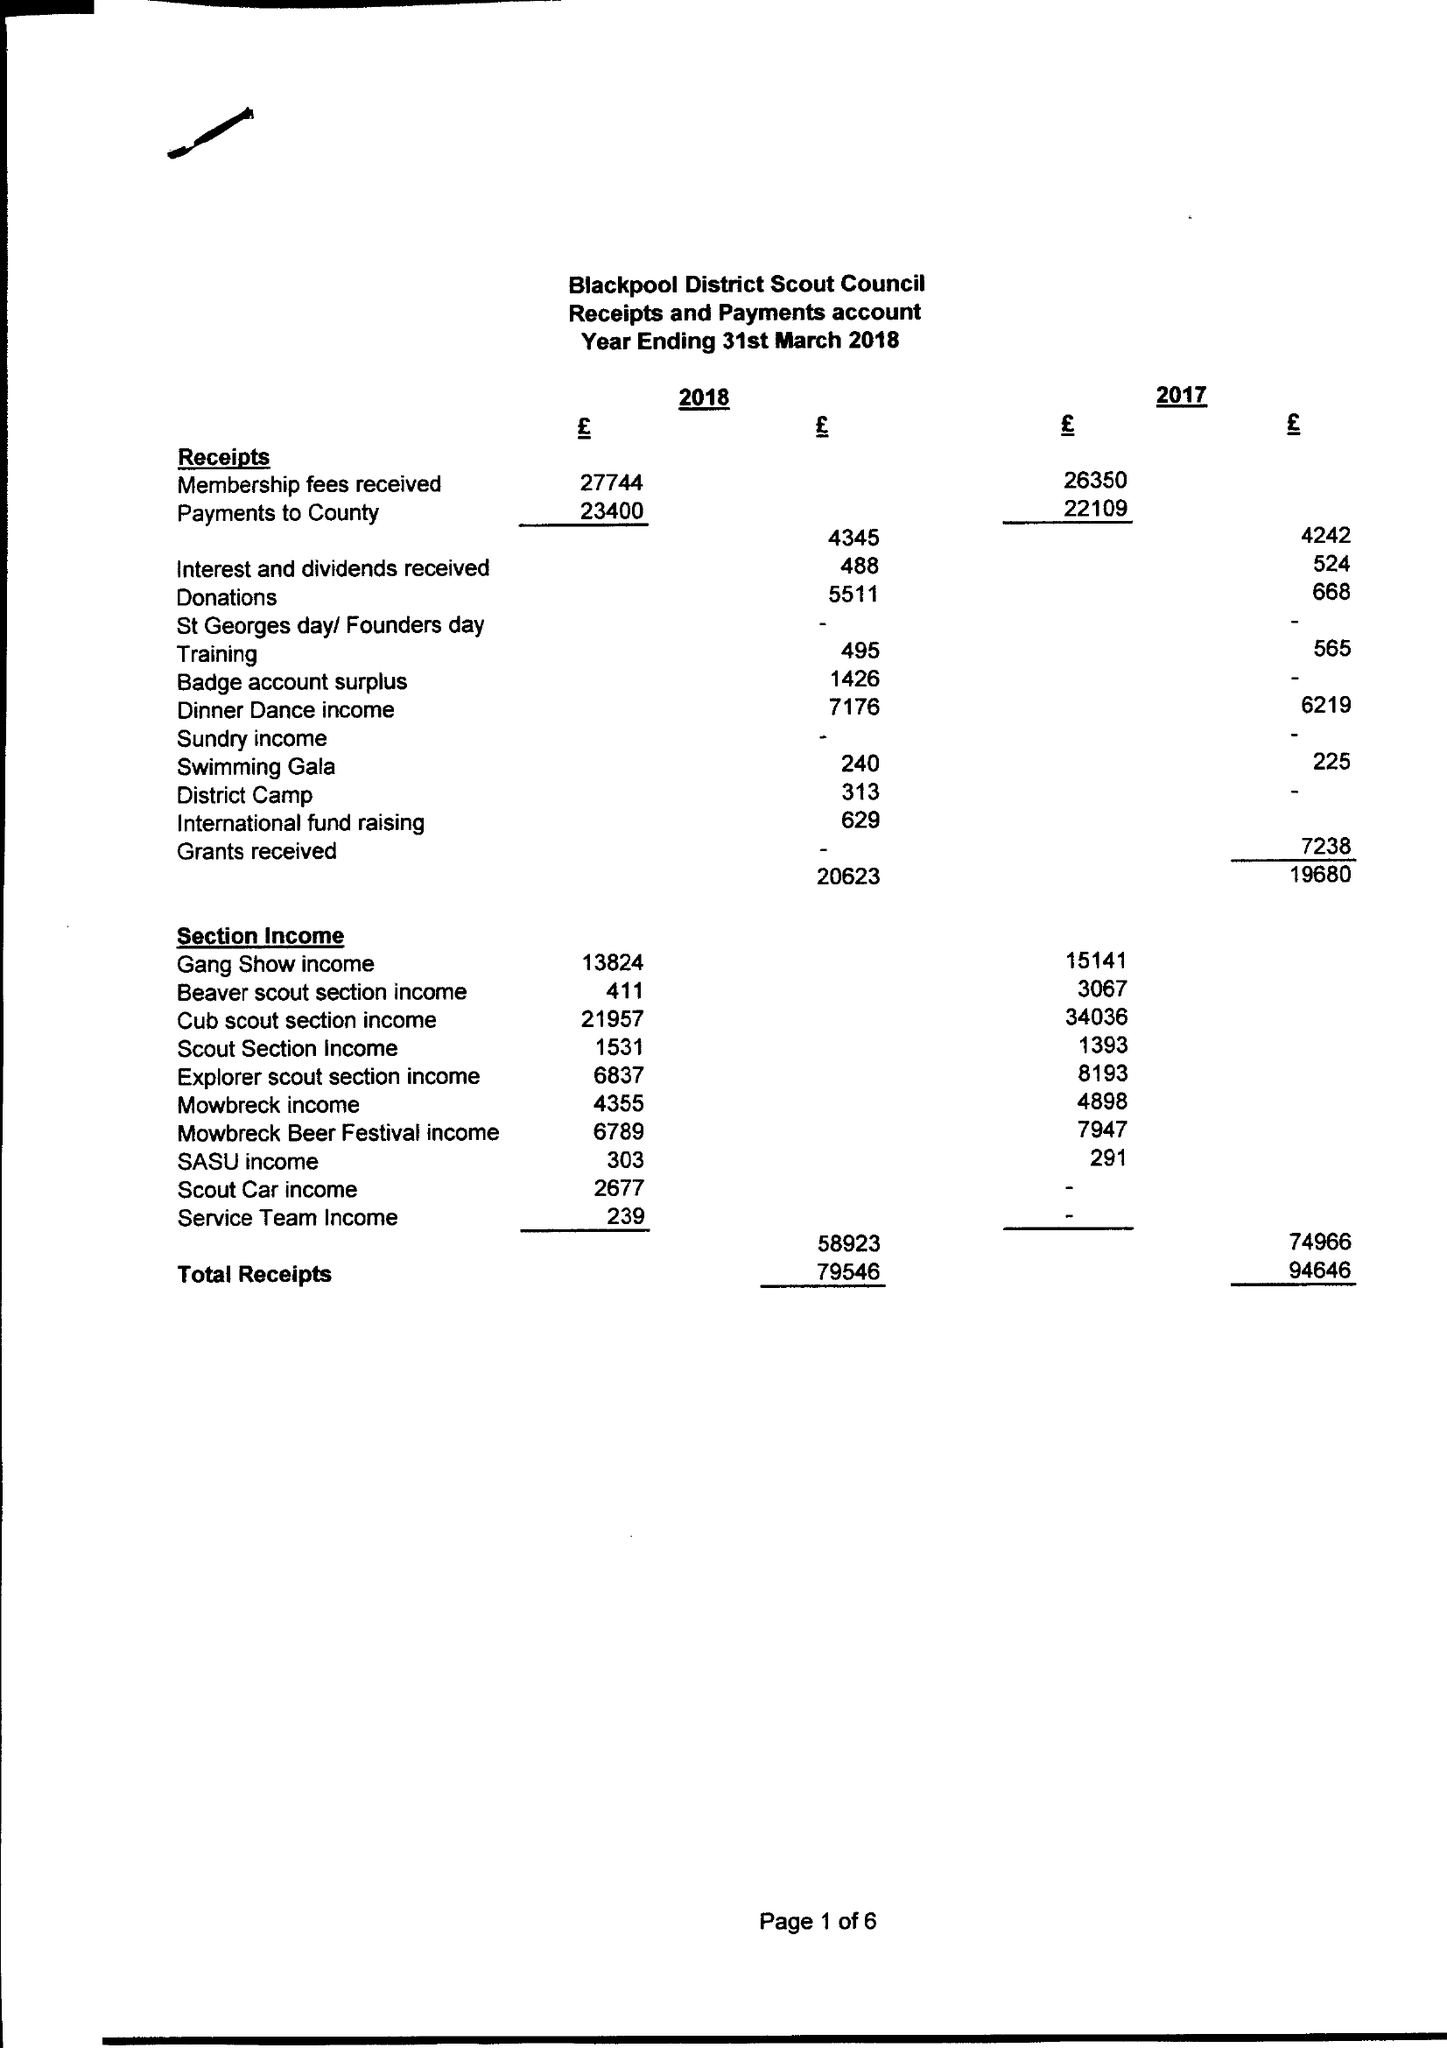What is the value for the report_date?
Answer the question using a single word or phrase. 2018-03-31 